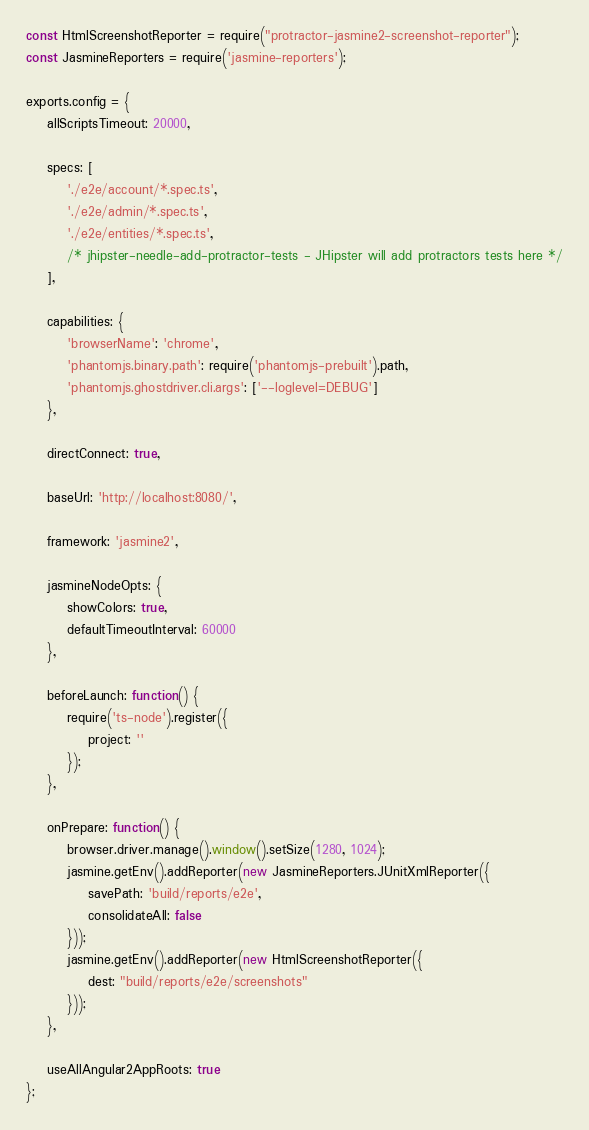Convert code to text. <code><loc_0><loc_0><loc_500><loc_500><_JavaScript_>const HtmlScreenshotReporter = require("protractor-jasmine2-screenshot-reporter");
const JasmineReporters = require('jasmine-reporters');

exports.config = {
    allScriptsTimeout: 20000,

    specs: [
        './e2e/account/*.spec.ts',
        './e2e/admin/*.spec.ts',
        './e2e/entities/*.spec.ts',
        /* jhipster-needle-add-protractor-tests - JHipster will add protractors tests here */
    ],

    capabilities: {
        'browserName': 'chrome',
        'phantomjs.binary.path': require('phantomjs-prebuilt').path,
        'phantomjs.ghostdriver.cli.args': ['--loglevel=DEBUG']
    },

    directConnect: true,

    baseUrl: 'http://localhost:8080/',

    framework: 'jasmine2',

    jasmineNodeOpts: {
        showColors: true,
        defaultTimeoutInterval: 60000
    },

    beforeLaunch: function() {
        require('ts-node').register({
            project: ''
        });
    },

    onPrepare: function() {
        browser.driver.manage().window().setSize(1280, 1024);
        jasmine.getEnv().addReporter(new JasmineReporters.JUnitXmlReporter({
            savePath: 'build/reports/e2e',
            consolidateAll: false
        }));
        jasmine.getEnv().addReporter(new HtmlScreenshotReporter({
            dest: "build/reports/e2e/screenshots"
        }));
    },

    useAllAngular2AppRoots: true
};
</code> 